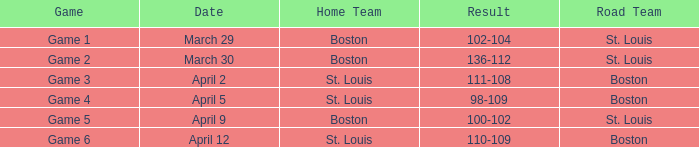What is the outcome of the game on april 9? 100-102. 